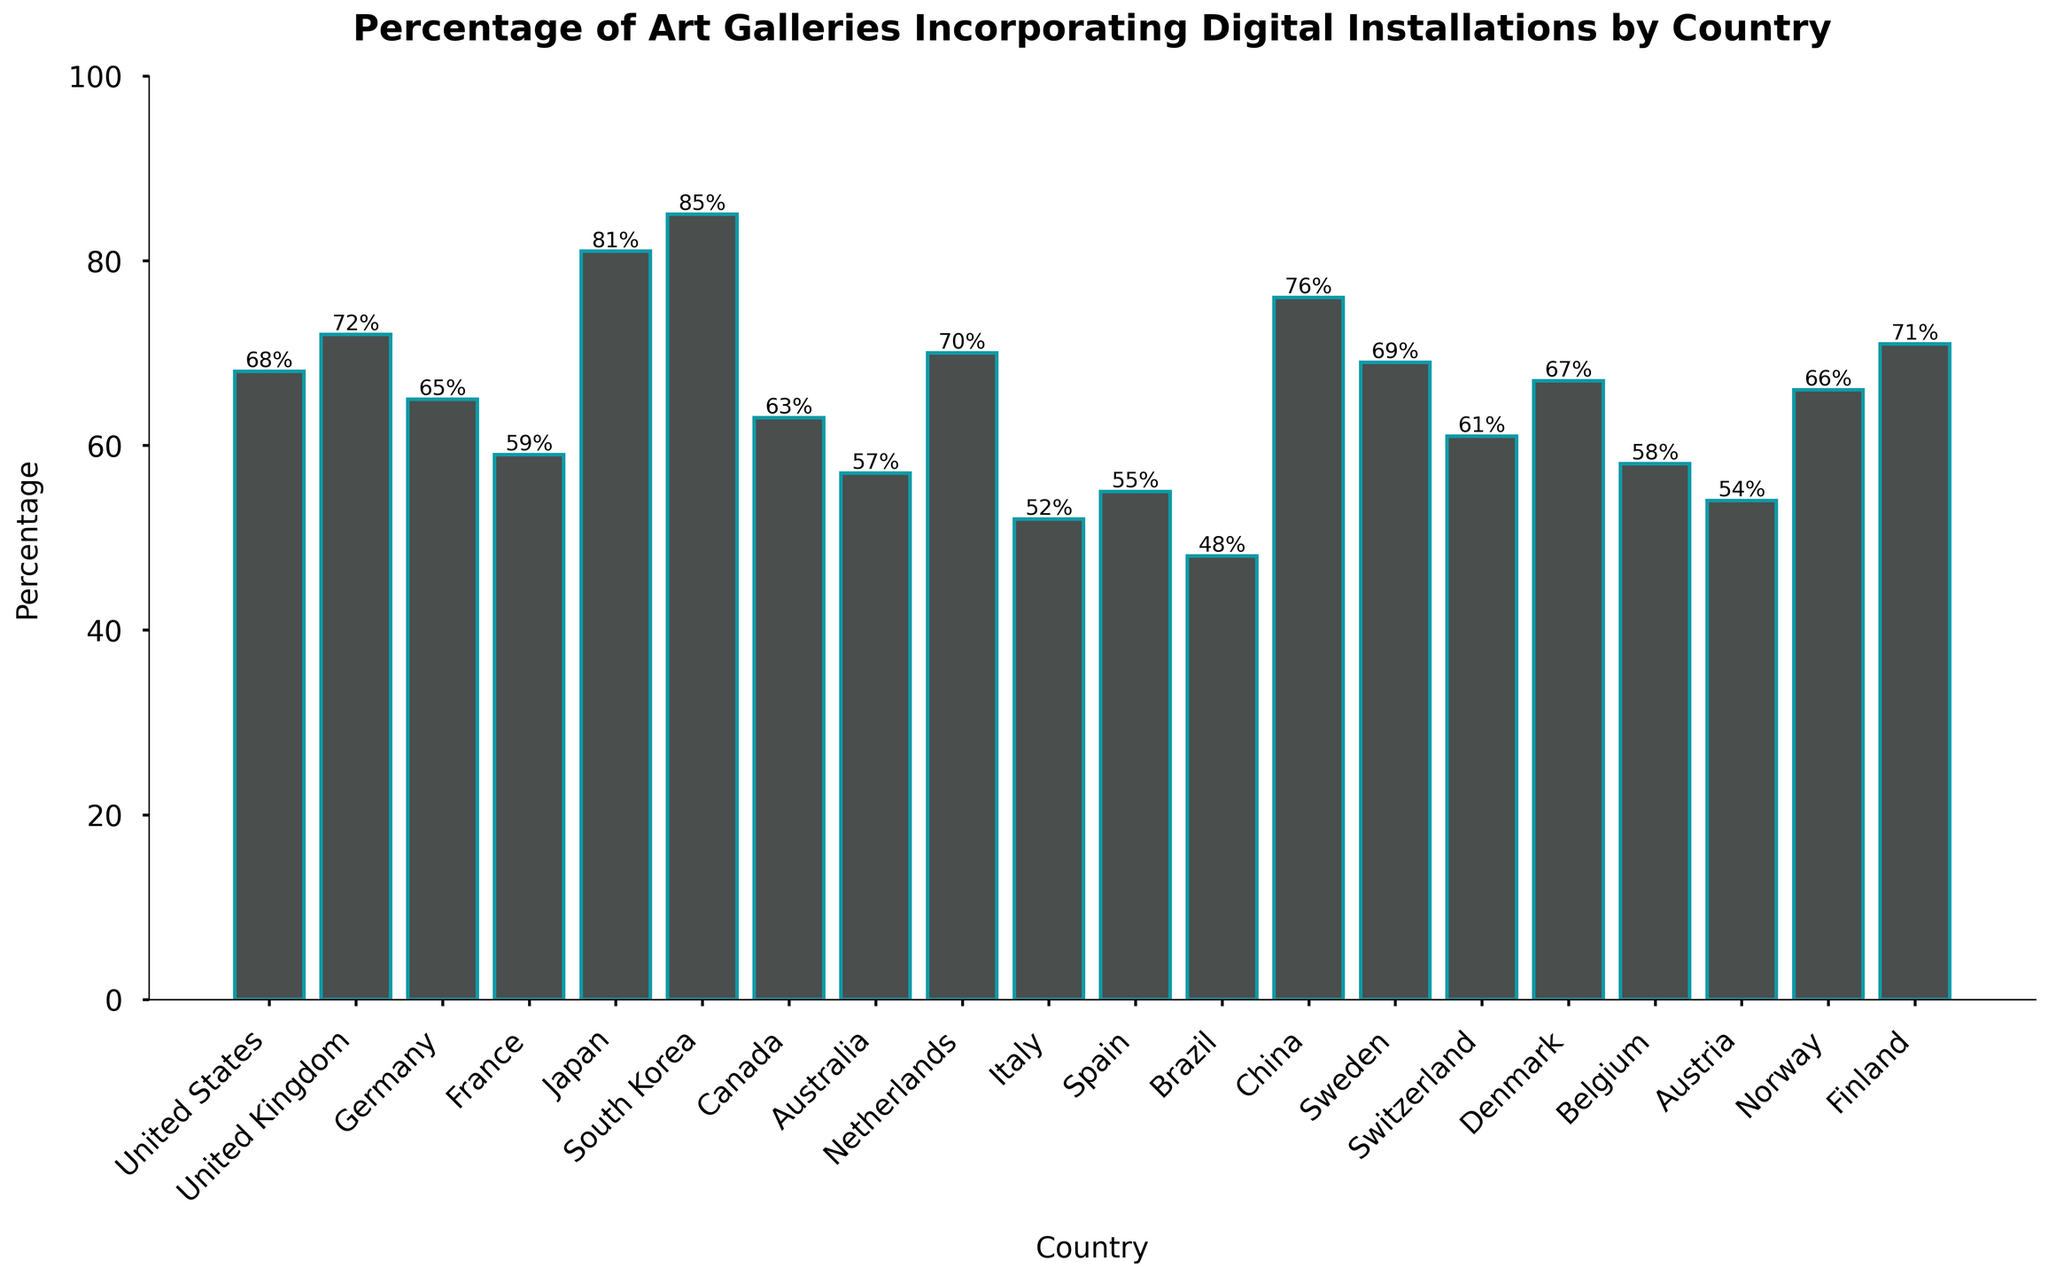Which country has the highest percentage of art galleries incorporating digital installations? The bar for South Korea is the tallest, indicating it has the highest percentage of art galleries with digital installations.
Answer: South Korea Which two countries have a percentage difference of more than 20% in art galleries incorporating digital installations? Comparing the percentages, South Korea (85%) and Brazil (48%) have a difference of 37%, which is more than 20%.
Answer: South Korea and Brazil What is the average percentage of art galleries incorporating digital installations across all countries? Add all the percentages and divide by the number of countries: (68 + 72 + 65 + 59 + 81 + 85 + 63 + 57 + 70 + 52 + 55 + 48 + 76 + 69 + 61 + 67 + 58 + 54 + 66 + 71) / 20 = 65.85%
Answer: 65.85% Which countries have a percentage close to the median value, and what is that median percentage? The median is the middle value; here: (between 63 and 66), so the countries are Germany (65%) and Norway (66%).
Answer: Germany and Norway at 65.5% How many countries have an incorporation rate of digital installations that is above 70%? Count the number of bars that exceed 70%: United Kingdom (72%), Japan (81%), South Korea (85%), China (76%), and Finland (71%) totaling five countries.
Answer: Five countries Which country has the lowest percentage of art galleries incorporating digital installations, and what is that percentage? The bar for Brazil is the shortest, with a percentage of 48%.
Answer: Brazil, 48% What is the range of percentage values for art galleries incorporating digital installations across the countries? Subtract the smallest percentage from the largest: 85% (South Korea) - 48% (Brazil) = 37%
Answer: 37% Compare the percentages of the United States and Canada; how much do they differ? The United States has 68% and Canada has 63%, differing by 5%.
Answer: 5% Which countries are below the overall average of 65.85% for digital installation incorporation? List countries with percentages below 65.85%: France (59%), Canada (63%), Australia (57%), Italy (52%), Spain (55%), Brazil (48%), Switzerland (61%), Belgium (58%), Austria (54%).
Answer: France, Canada, Australia, Italy, Spain, Brazil, Switzerland, Belgium, Austria 